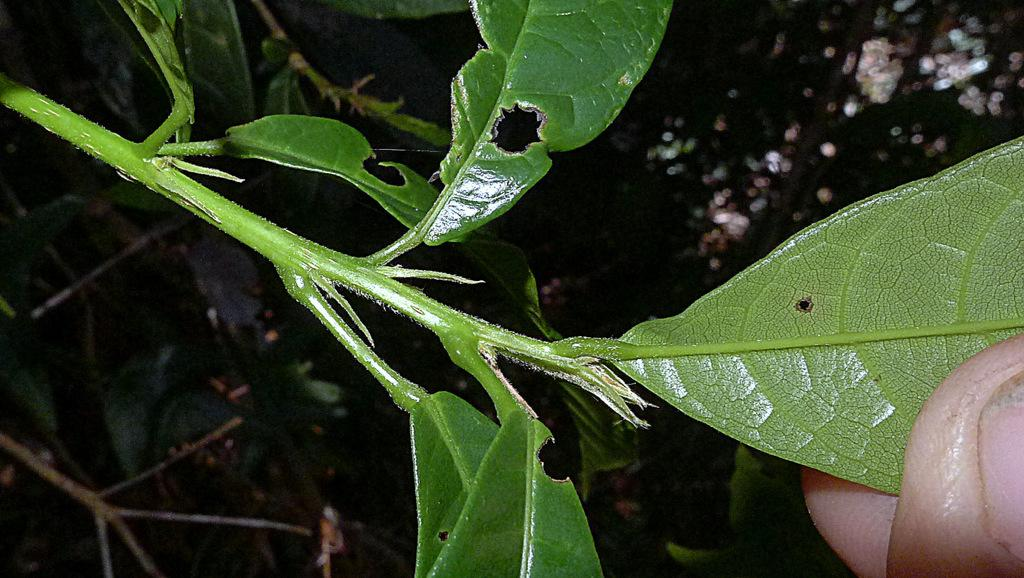What is the main subject of the image? The main subject of the image is a stem with leaves. Can you describe any other elements in the image? Yes, fingers are visible in the right bottom corner of the image. What can be observed about the background of the image? The background of the image is dark. What type of jewel is being held by the fingers in the image? There is no jewel present in the image; only a stem with leaves and fingers are visible. 